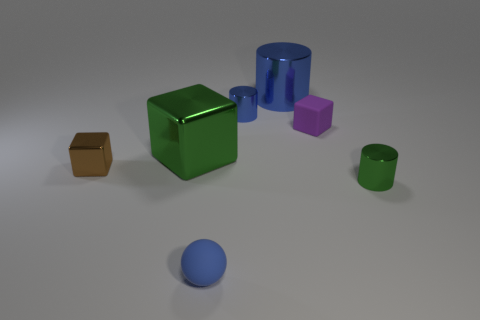Subtract all gray blocks. Subtract all purple balls. How many blocks are left? 3 Add 1 green metallic balls. How many objects exist? 8 Subtract all balls. How many objects are left? 6 Subtract all small blue rubber spheres. Subtract all large blue balls. How many objects are left? 6 Add 2 large blocks. How many large blocks are left? 3 Add 2 blue rubber things. How many blue rubber things exist? 3 Subtract 1 purple blocks. How many objects are left? 6 